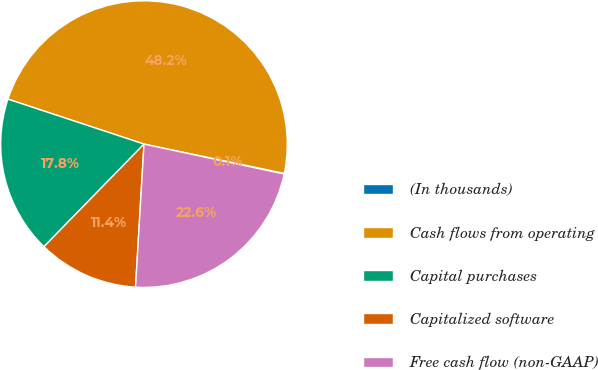<chart> <loc_0><loc_0><loc_500><loc_500><pie_chart><fcel>(In thousands)<fcel>Cash flows from operating<fcel>Capital purchases<fcel>Capitalized software<fcel>Free cash flow (non-GAAP)<nl><fcel>0.08%<fcel>48.2%<fcel>17.78%<fcel>11.36%<fcel>22.59%<nl></chart> 